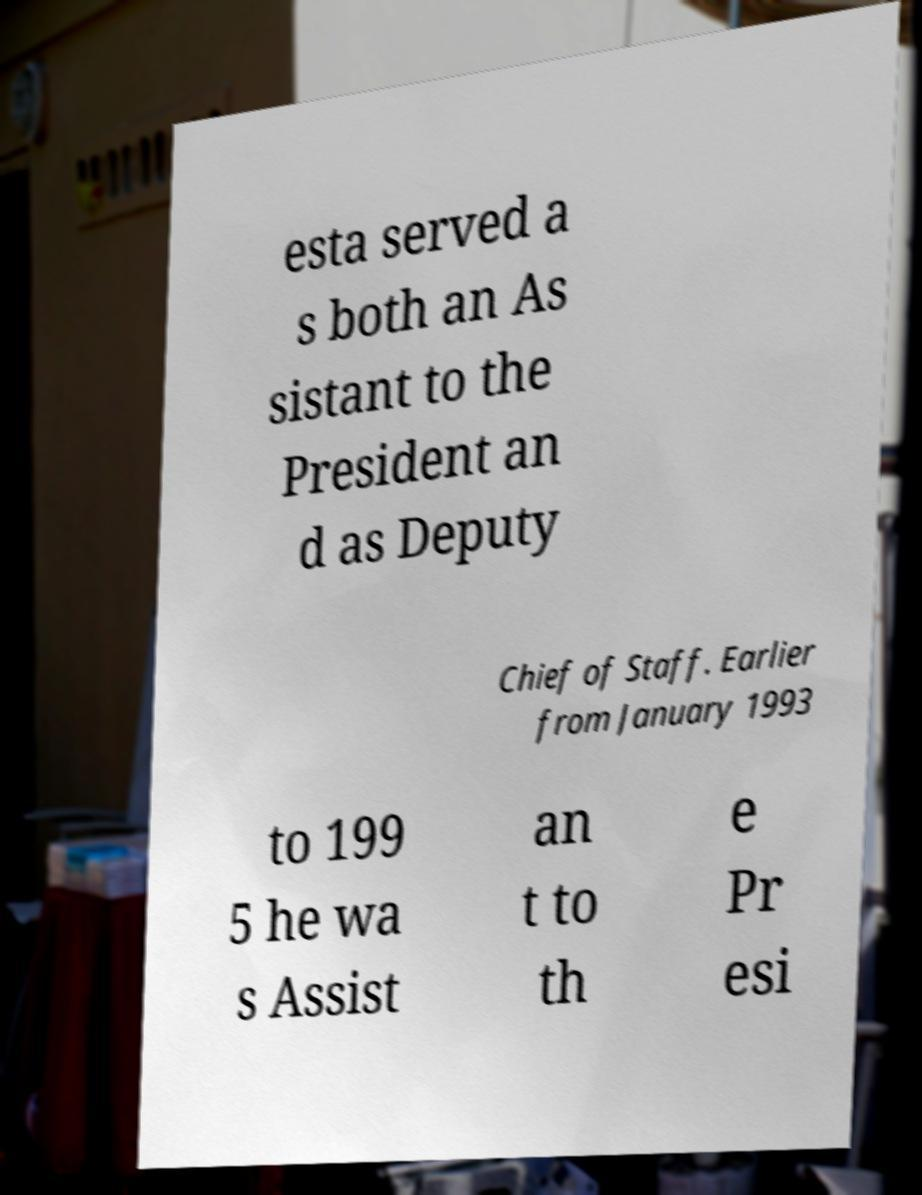There's text embedded in this image that I need extracted. Can you transcribe it verbatim? esta served a s both an As sistant to the President an d as Deputy Chief of Staff. Earlier from January 1993 to 199 5 he wa s Assist an t to th e Pr esi 